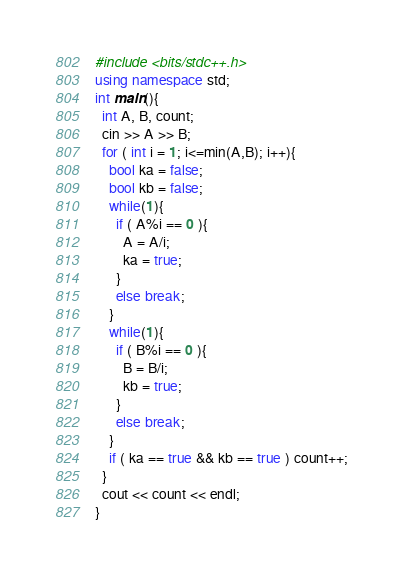Convert code to text. <code><loc_0><loc_0><loc_500><loc_500><_C++_>#include <bits/stdc++.h>
using namespace std;
int main(){
  int A, B, count;
  cin >> A >> B;
  for ( int i = 1; i<=min(A,B); i++){
    bool ka = false;
    bool kb = false;
    while(1){
      if ( A%i == 0 ){
        A = A/i;
        ka = true;
      }
      else break;
    }
    while(1){
      if ( B%i == 0 ){
        B = B/i;
        kb = true;
      }
      else break;
    }
    if ( ka == true && kb == true ) count++;
  }
  cout << count << endl;
}</code> 